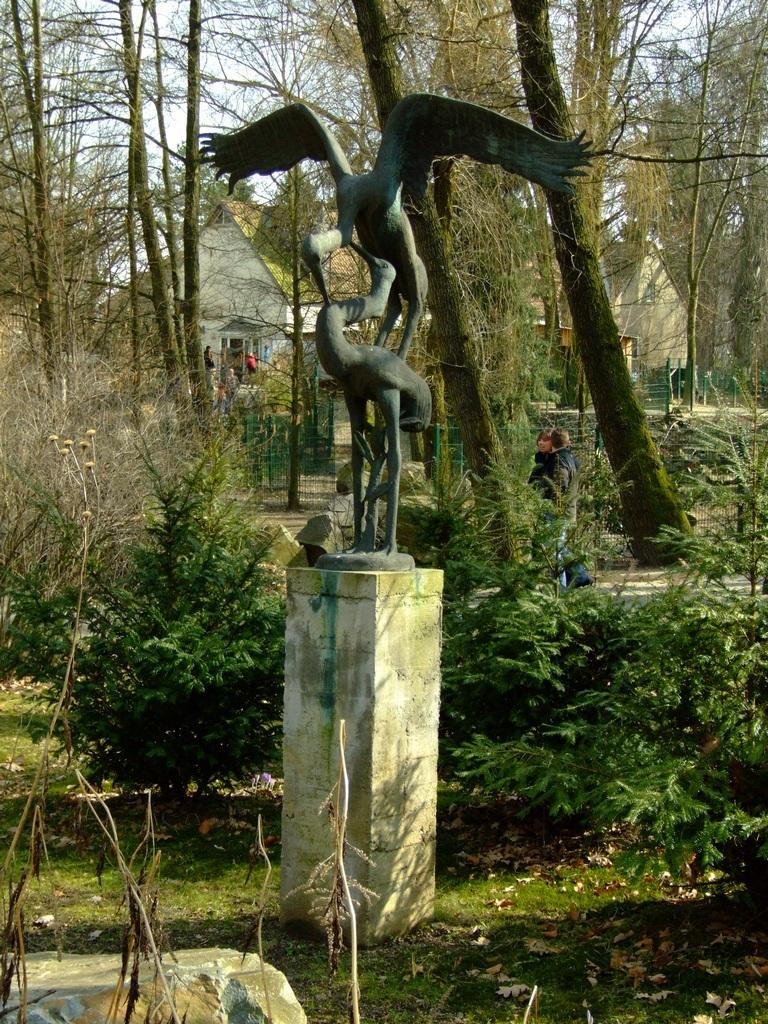What is the main subject of the image? There is a statue of a bird in the image. What can be seen in the background of the image? There are people walking, a white building, and green trees in the background of the image. What is the color of the sky in the image? The sky is white in the image. Where is the crate located in the image? There is no crate present in the image. What type of brake is used by the ants in the image? There are no ants or brakes present in the image. 